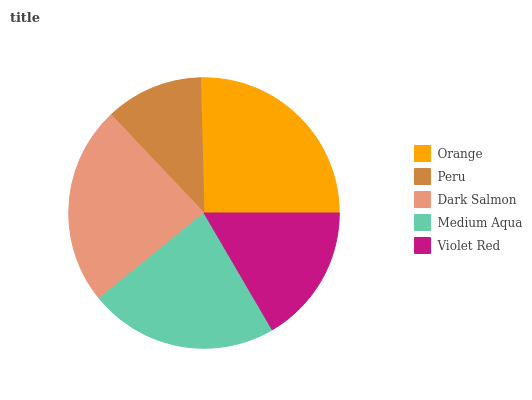Is Peru the minimum?
Answer yes or no. Yes. Is Orange the maximum?
Answer yes or no. Yes. Is Dark Salmon the minimum?
Answer yes or no. No. Is Dark Salmon the maximum?
Answer yes or no. No. Is Dark Salmon greater than Peru?
Answer yes or no. Yes. Is Peru less than Dark Salmon?
Answer yes or no. Yes. Is Peru greater than Dark Salmon?
Answer yes or no. No. Is Dark Salmon less than Peru?
Answer yes or no. No. Is Medium Aqua the high median?
Answer yes or no. Yes. Is Medium Aqua the low median?
Answer yes or no. Yes. Is Peru the high median?
Answer yes or no. No. Is Dark Salmon the low median?
Answer yes or no. No. 